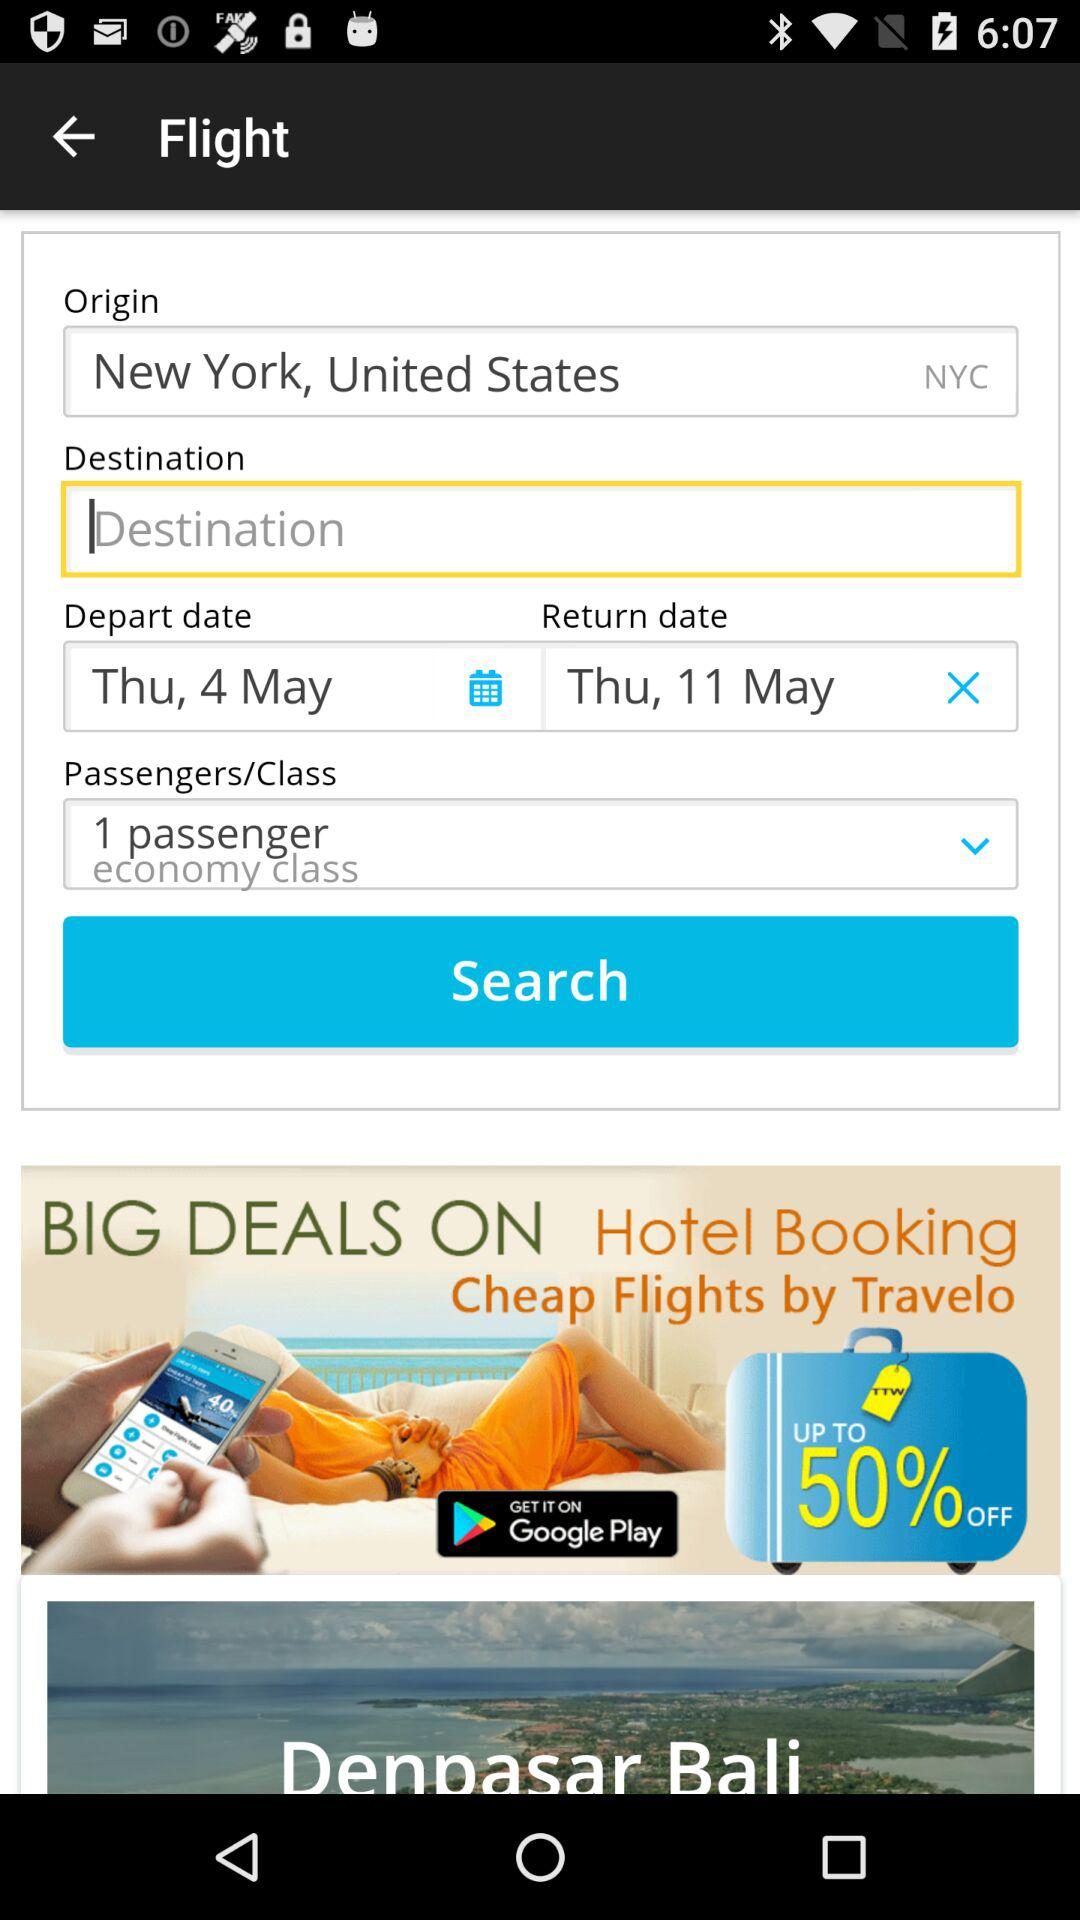Can you tell if any special deals or offers are featured in the booking app? Yes, the booking app advertises 'BIG DEALS ON Hotel Booking' along with an offer of 'Cheap Flights by Travelo', including a discount of up to 50% off. 